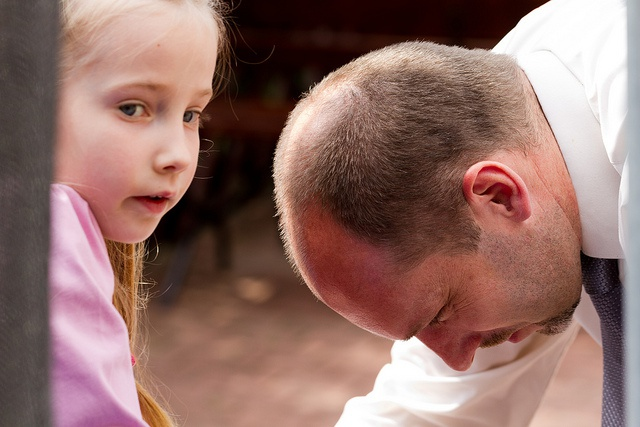Describe the objects in this image and their specific colors. I can see people in gray, white, brown, maroon, and tan tones, people in gray, lightpink, brown, and pink tones, and tie in gray and black tones in this image. 